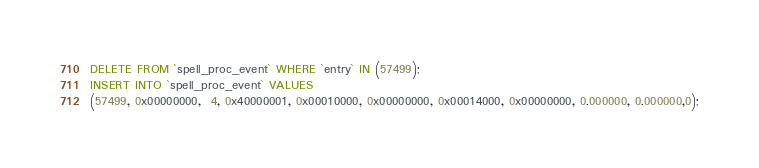Convert code to text. <code><loc_0><loc_0><loc_500><loc_500><_SQL_>DELETE FROM `spell_proc_event` WHERE `entry` IN (57499);
INSERT INTO `spell_proc_event` VALUES
(57499, 0x00000000,  4, 0x40000001, 0x00010000, 0x00000000, 0x00014000, 0x00000000, 0.000000, 0.000000,0);
</code> 